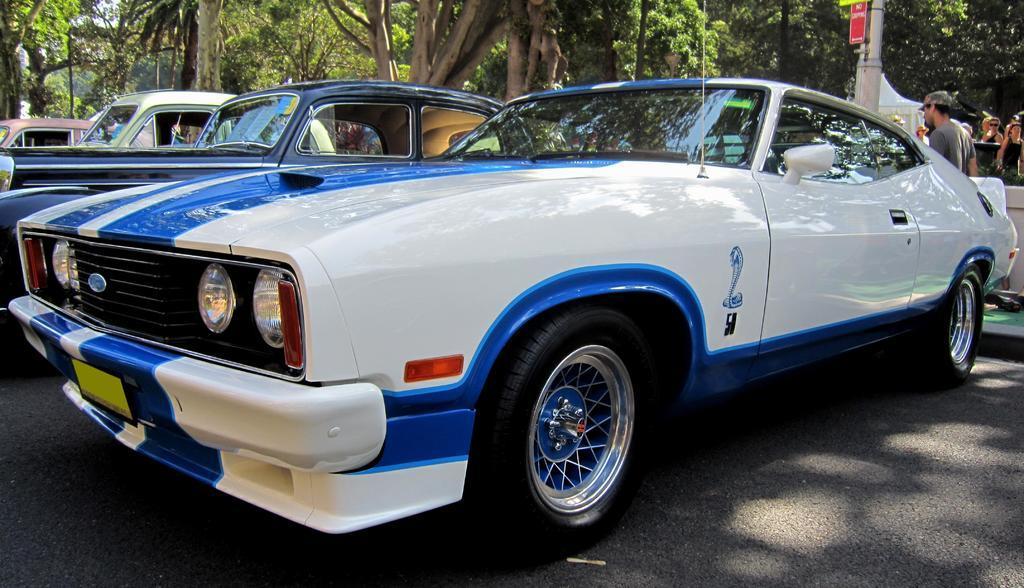What can be seen on the road in the image? There are cars parked on the road in the image. What are the people behind the parked cars doing? The people standing behind the parked cars are not explicitly doing anything in the image. What can be seen in the distance in the image? There are trees visible in the background of the image. What type of yarn is being used as a punishment for the cars in the image? There is no yarn or punishment present in the image; it simply shows parked cars on the road with people standing behind them and trees in the background. 